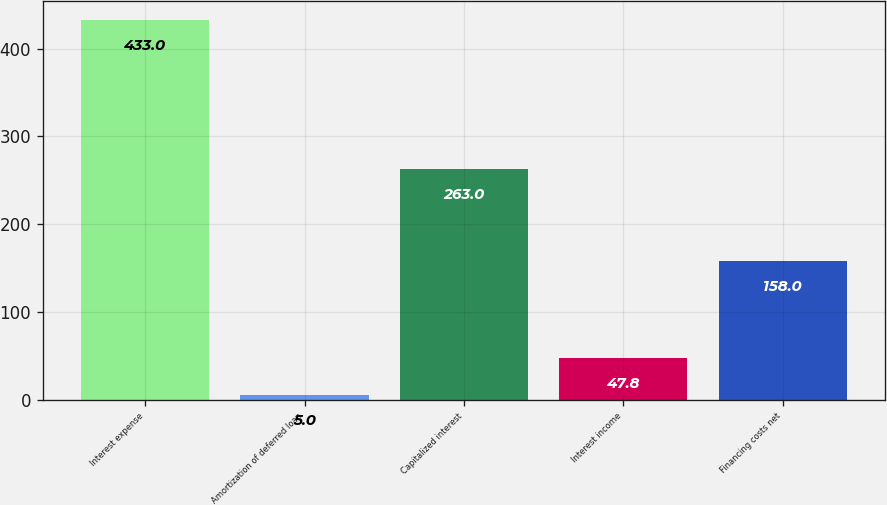Convert chart to OTSL. <chart><loc_0><loc_0><loc_500><loc_500><bar_chart><fcel>Interest expense<fcel>Amortization of deferred loan<fcel>Capitalized interest<fcel>Interest income<fcel>Financing costs net<nl><fcel>433<fcel>5<fcel>263<fcel>47.8<fcel>158<nl></chart> 